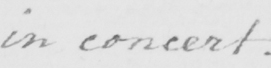Please provide the text content of this handwritten line. in concert. 